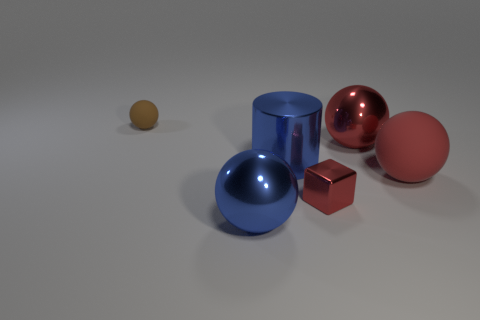What size is the metal sphere that is the same color as the big matte object?
Your response must be concise. Large. How many tiny brown things are left of the metal cube?
Make the answer very short. 1. There is a matte sphere right of the tiny object that is on the left side of the large blue metal thing that is in front of the red metallic block; what is its size?
Make the answer very short. Large. Are there any brown matte balls in front of the thing to the left of the metal sphere in front of the tiny red cube?
Your answer should be very brief. No. Is the number of big metal things greater than the number of rubber spheres?
Your answer should be compact. Yes. What color is the matte thing that is right of the big blue metallic cylinder?
Your answer should be very brief. Red. Are there more tiny brown rubber things in front of the blue ball than large spheres?
Provide a succinct answer. No. Does the small cube have the same material as the tiny brown thing?
Ensure brevity in your answer.  No. What number of other things are the same shape as the large rubber thing?
Offer a terse response. 3. Is there anything else that is the same material as the tiny ball?
Offer a terse response. Yes. 